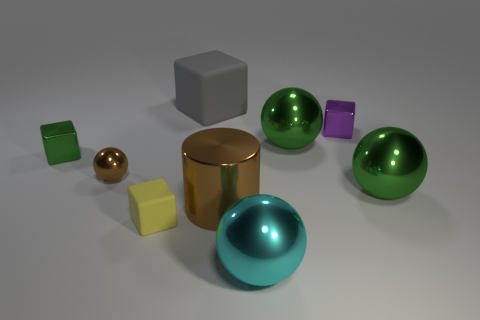There is a green metal thing that is in front of the brown metal ball; does it have the same size as the cyan metallic thing?
Your response must be concise. Yes. How many metal objects are either big cyan objects or gray objects?
Give a very brief answer. 1. What number of big brown shiny things are behind the rubber object that is behind the big shiny cylinder?
Make the answer very short. 0. The metallic thing that is to the left of the large matte block and in front of the green shiny cube has what shape?
Your response must be concise. Sphere. What material is the small object on the right side of the yellow matte object left of the small metallic block that is right of the big brown metal cylinder?
Keep it short and to the point. Metal. There is a object that is the same color as the big metal cylinder; what size is it?
Your response must be concise. Small. What is the material of the yellow object?
Ensure brevity in your answer.  Rubber. Is the material of the gray object the same as the small cube in front of the tiny brown shiny sphere?
Offer a terse response. Yes. The matte object that is on the left side of the rubber cube that is behind the yellow thing is what color?
Keep it short and to the point. Yellow. How big is the cube that is both behind the green block and in front of the large matte object?
Provide a succinct answer. Small. 